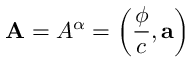Convert formula to latex. <formula><loc_0><loc_0><loc_500><loc_500>A = A ^ { \alpha } = \left ( { \frac { \phi } { c } } , \vec { a } \right )</formula> 